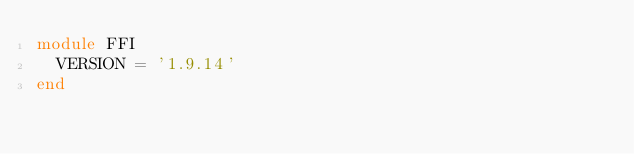Convert code to text. <code><loc_0><loc_0><loc_500><loc_500><_Ruby_>module FFI
  VERSION = '1.9.14'
end

</code> 